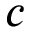<formula> <loc_0><loc_0><loc_500><loc_500>c</formula> 